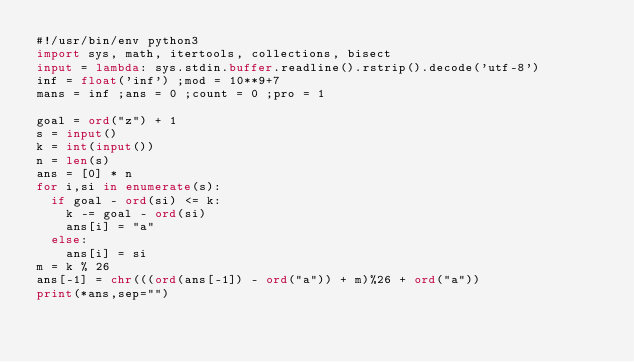<code> <loc_0><loc_0><loc_500><loc_500><_Python_>#!/usr/bin/env python3
import sys, math, itertools, collections, bisect
input = lambda: sys.stdin.buffer.readline().rstrip().decode('utf-8')
inf = float('inf') ;mod = 10**9+7
mans = inf ;ans = 0 ;count = 0 ;pro = 1

goal = ord("z") + 1 
s = input()
k = int(input())
n = len(s)
ans = [0] * n
for i,si in enumerate(s):
  if goal - ord(si) <= k:
    k -= goal - ord(si)
    ans[i] = "a"
  else:
    ans[i] = si
m = k % 26
ans[-1] = chr(((ord(ans[-1]) - ord("a")) + m)%26 + ord("a"))
print(*ans,sep="")</code> 